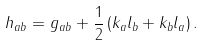Convert formula to latex. <formula><loc_0><loc_0><loc_500><loc_500>h _ { a b } = g _ { a b } + \frac { 1 } { 2 } \left ( k _ { a } l _ { b } + k _ { b } l _ { a } \right ) .</formula> 